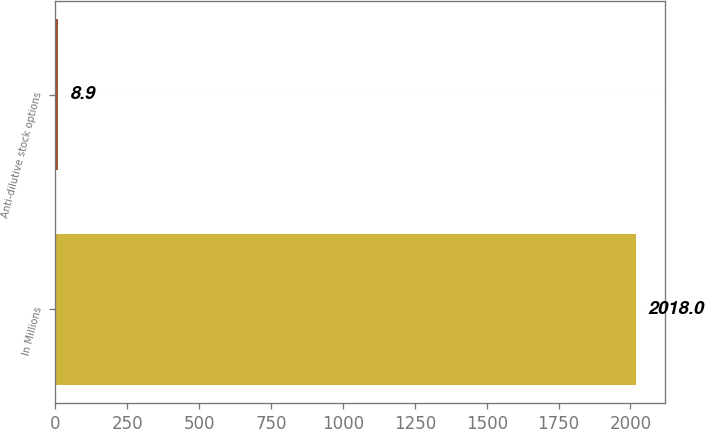<chart> <loc_0><loc_0><loc_500><loc_500><bar_chart><fcel>In Millions<fcel>Anti-dilutive stock options<nl><fcel>2018<fcel>8.9<nl></chart> 